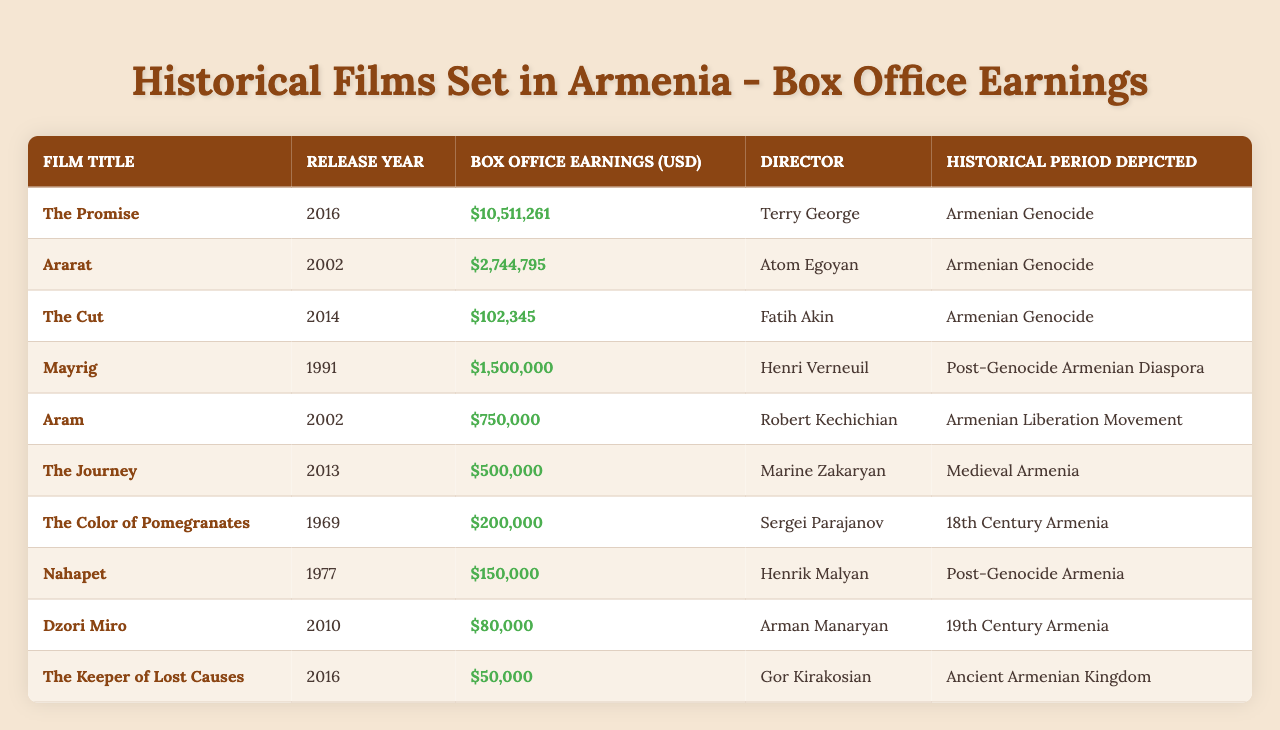What is the highest box office earning among the films listed? By reviewing the "Box Office Earnings (USD)" column, the film "The Promise" has the highest earnings of $10,511,261.
Answer: $10,511,261 Which film directed by Atom Egoyan depicts the Armenian Genocide? The film "Ararat," directed by Atom Egoyan, depicts the Armenian Genocide, as seen in the "Director" and "Historical Period Depicted" columns.
Answer: Ararat How many films have box office earnings less than $100,000? From the table, only "The Cut," "Nahapet," and "Dzori Miro" have earnings below $100,000. Thus, there are three films in total.
Answer: 3 What is the total box office earning of all films depicting the Armenian Genocide? The films "The Promise," "Ararat," and "The Cut" depict the Armenian Genocide with box office earnings of $10,511,261, $2,744,795, and $102,345, respectively. Summing these gives $10,511,261 + $2,744,795 + $102,345 = $13,358,401.
Answer: $13,358,401 Was "The Journey" released before "The Promise"? "The Journey" was released in 2013, while "The Promise" was released in 2016. Therefore, "The Journey" was released before "The Promise."
Answer: Yes Which historical period has the lowest average box office earnings based on the films listed? To find the period with the lowest average, calculate the earnings for each historical period: Armenian Genocide: ($10,511,261 + $2,744,795 + $102,345) / 3 = $4,786,800.67; Post-Genocide Armenian Diaspora: ($1,500,000 + $150,000) / 2 = $825,000; Armenian Liberation Movement: $750,000; Medieval Armenia: $500,000; 18th Century Armenia: $200,000; 19th Century Armenia: $80,000; Ancient Armenian Kingdom: $50,000. The lowest is the Ancient Armenian Kingdom with an average of $50,000.
Answer: Ancient Armenian Kingdom What year saw the release of the film with the second-highest box office earnings? The film with the second-highest earnings is "Ararat," which was released in 2002, earning $2,744,795.
Answer: 2002 How many films are listed that depict the Armenian liberation movement or earlier? The films depicting the Armenian liberation movement or earlier include "The Color of Pomegranates" (1969), "Nahapet" (1977), and "The Keeper of Lost Causes" (2016), making a total of three films.
Answer: 3 What is the average box office earning of all films released after the year 2000? Films released after 2000 include "Ararat" (2002, $2,744,795), "Mayrig" (1991, $1,500,000), "Aram" (2002, $750,000), "The Journey" (2013, $500,000), "The Promise" (2016, $10,511,261), "The Cut" (2014, $102,345), and "Dzori Miro" (2010, $80,000). Adding these gives $2,744,795 + $1,500,000 + $750,000 + $500,000 + $10,511,261 + $102,345 + $80,000 = $15,688,401 and dividing by 7 gives an average of about $2,241,200.14.
Answer: $2,241,200.14 What percentage of the films listed are about the Armenian Genocide? There are three films out of a total of ten that depict the Armenian Genocide: "The Promise," "Ararat," and "The Cut." To find the percentage, the calculation is (3/10) * 100 = 30%.
Answer: 30% 